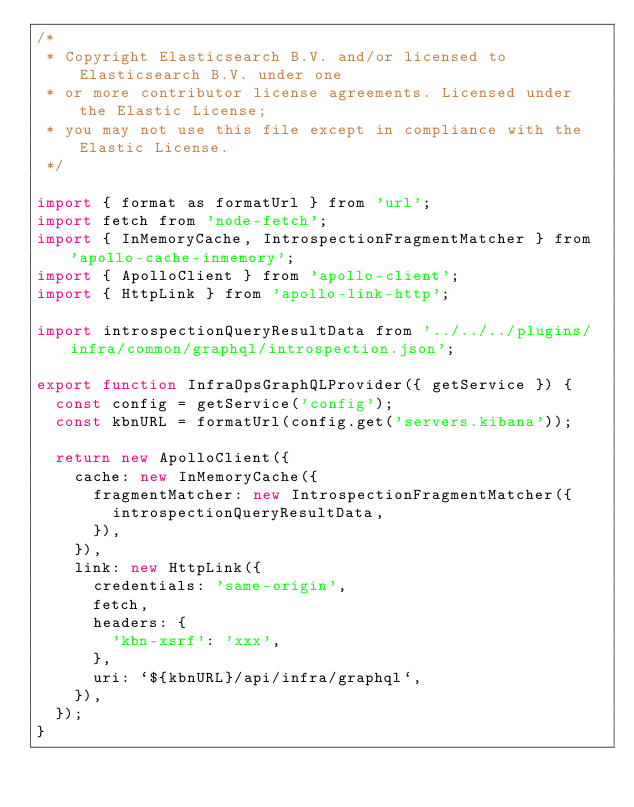<code> <loc_0><loc_0><loc_500><loc_500><_JavaScript_>/*
 * Copyright Elasticsearch B.V. and/or licensed to Elasticsearch B.V. under one
 * or more contributor license agreements. Licensed under the Elastic License;
 * you may not use this file except in compliance with the Elastic License.
 */

import { format as formatUrl } from 'url';
import fetch from 'node-fetch';
import { InMemoryCache, IntrospectionFragmentMatcher } from 'apollo-cache-inmemory';
import { ApolloClient } from 'apollo-client';
import { HttpLink } from 'apollo-link-http';

import introspectionQueryResultData from '../../../plugins/infra/common/graphql/introspection.json';

export function InfraOpsGraphQLProvider({ getService }) {
  const config = getService('config');
  const kbnURL = formatUrl(config.get('servers.kibana'));

  return new ApolloClient({
    cache: new InMemoryCache({
      fragmentMatcher: new IntrospectionFragmentMatcher({
        introspectionQueryResultData,
      }),
    }),
    link: new HttpLink({
      credentials: 'same-origin',
      fetch,
      headers: {
        'kbn-xsrf': 'xxx',
      },
      uri: `${kbnURL}/api/infra/graphql`,
    }),
  });
}
</code> 